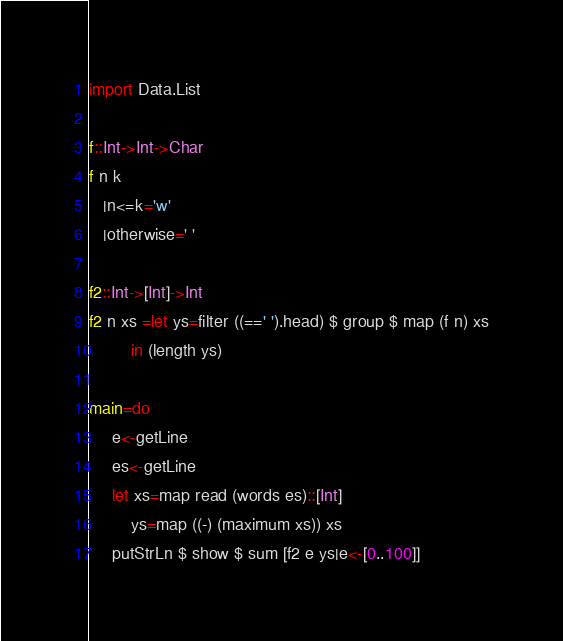Convert code to text. <code><loc_0><loc_0><loc_500><loc_500><_Haskell_>import Data.List

f::Int->Int->Char
f n k
   |n<=k='w'
   |otherwise=' '

f2::Int->[Int]->Int
f2 n xs =let ys=filter ((==' ').head) $ group $ map (f n) xs
         in (length ys)

main=do
     e<-getLine
     es<-getLine
     let xs=map read (words es)::[Int]
         ys=map ((-) (maximum xs)) xs
     putStrLn $ show $ sum [f2 e ys|e<-[0..100]]</code> 